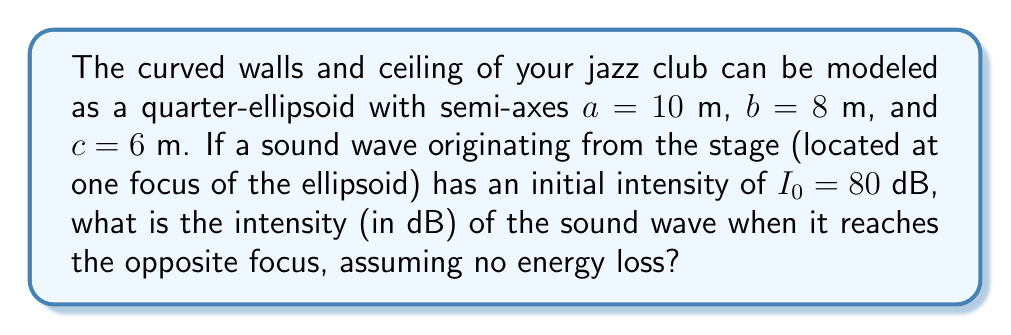Provide a solution to this math problem. To solve this problem, we'll follow these steps:

1) First, we need to find the focal points of the ellipsoid. For a quarter-ellipsoid with semi-axes $a$, $b$, and $c$, the distance between the foci is given by:

   $$f = 2\sqrt{a^2 - c^2}$$

2) Substituting our values:

   $$f = 2\sqrt{10^2 - 6^2} = 2\sqrt{64} = 16\text{ m}$$

3) The total distance the sound wave travels is twice this focal length:

   $$d = 2f = 32\text{ m}$$

4) In an ideal situation with no energy loss, the product of intensity and surface area remains constant as the wave expands. This is known as the inverse square law:

   $$I_1 A_1 = I_2 A_2$$

   where $I_1$ and $A_1$ are the initial intensity and area, and $I_2$ and $A_2$ are the final intensity and area.

5) The areas in this case are the surface areas of expanding spheres. The ratio of these areas is:

   $$\frac{A_2}{A_1} = \frac{4\pi r_2^2}{4\pi r_1^2} = \frac{r_2^2}{r_1^2} = \frac{d^2}{r_1^2} = \frac{32^2}{1^2} = 1024$$

   (assuming the initial radius $r_1$ is 1 m, as the sound originates from a point source)

6) Therefore:

   $$I_2 = I_1 \cdot \frac{1}{1024} = I_1 - 10\log_{10}(1024) = I_1 - 30\text{ dB}$$

7) Given the initial intensity $I_1 = 80$ dB, the final intensity is:

   $$I_2 = 80 - 30 = 50\text{ dB}$$
Answer: 50 dB 